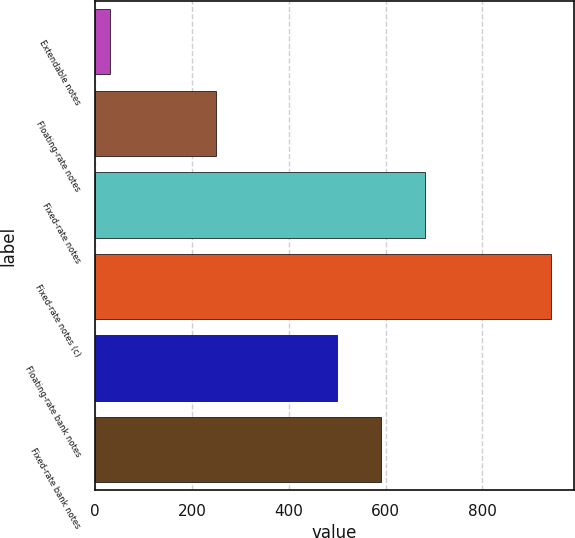<chart> <loc_0><loc_0><loc_500><loc_500><bar_chart><fcel>Extendable notes<fcel>Floating-rate notes<fcel>Fixed-rate notes<fcel>Fixed-rate notes (c)<fcel>Floating-rate bank notes<fcel>Fixed-rate bank notes<nl><fcel>31<fcel>250<fcel>682.2<fcel>942<fcel>500<fcel>591.1<nl></chart> 